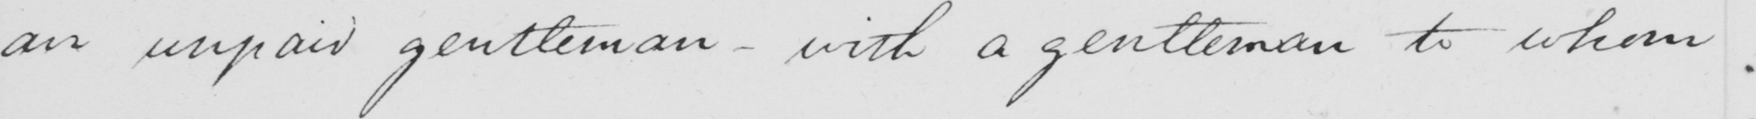Please provide the text content of this handwritten line. an unpaid gentleman  _  with a gentleman to whom 